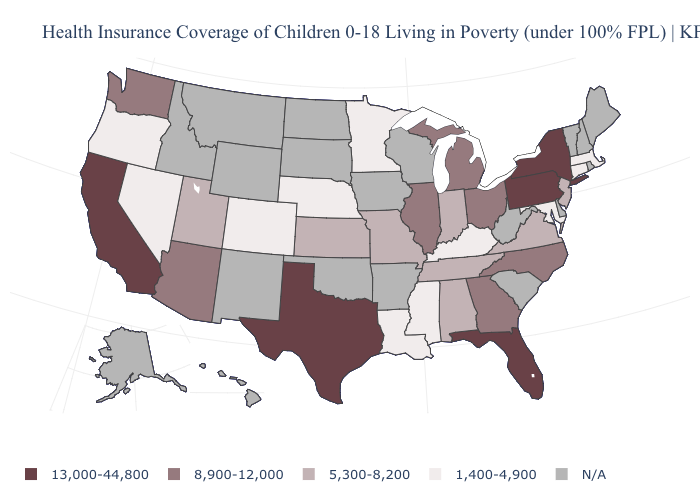What is the value of Massachusetts?
Concise answer only. 1,400-4,900. What is the value of Iowa?
Concise answer only. N/A. Does Colorado have the lowest value in the West?
Write a very short answer. Yes. What is the value of South Carolina?
Give a very brief answer. N/A. Among the states that border South Dakota , which have the highest value?
Concise answer only. Minnesota, Nebraska. Does the map have missing data?
Answer briefly. Yes. How many symbols are there in the legend?
Quick response, please. 5. Does Florida have the highest value in the USA?
Answer briefly. Yes. Among the states that border Idaho , which have the lowest value?
Write a very short answer. Nevada, Oregon. Does Illinois have the highest value in the MidWest?
Be succinct. Yes. Which states hav the highest value in the West?
Quick response, please. California. Name the states that have a value in the range 1,400-4,900?
Quick response, please. Colorado, Connecticut, Kentucky, Louisiana, Maryland, Massachusetts, Minnesota, Mississippi, Nebraska, Nevada, Oregon. Among the states that border New Hampshire , which have the highest value?
Give a very brief answer. Massachusetts. Does the map have missing data?
Keep it brief. Yes. Name the states that have a value in the range 13,000-44,800?
Be succinct. California, Florida, New York, Pennsylvania, Texas. 